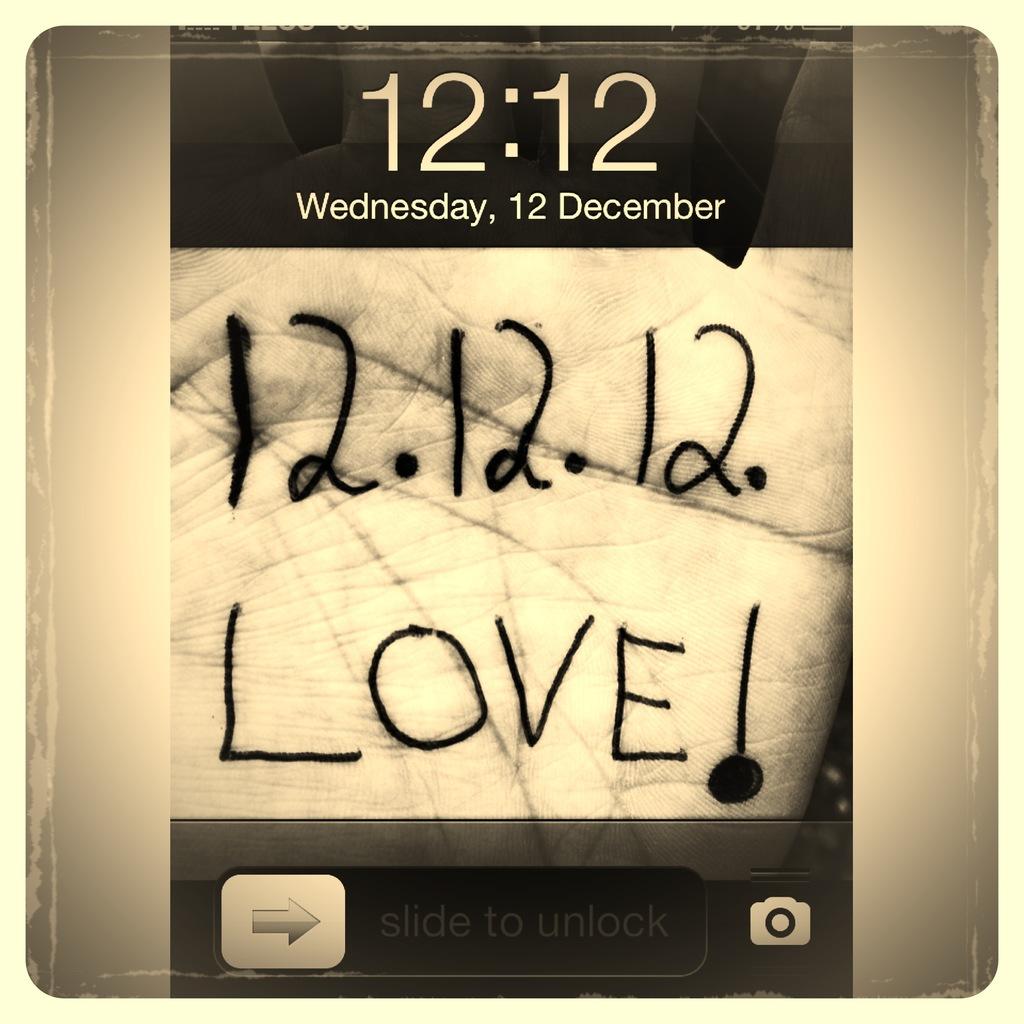What is the date listed in this screenshot?
Ensure brevity in your answer.  December 12th. What day is it?
Offer a very short reply. Wednesday. 